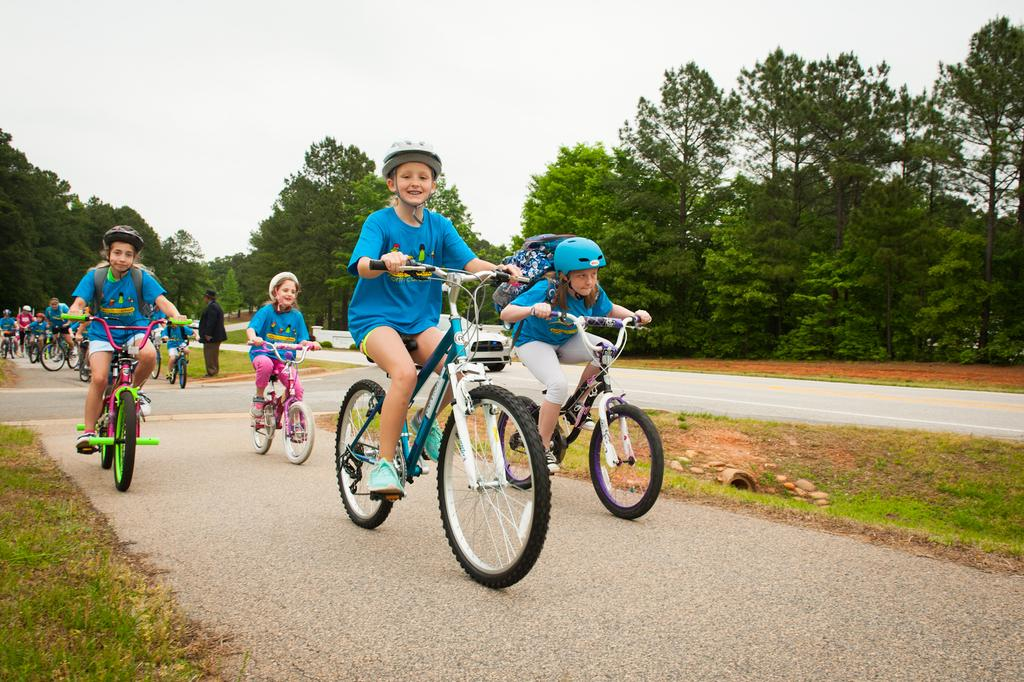What can be seen in the image involving children? There are children in the image, and they are riding bicycles. What are the children riding in the image? The children are riding bicycles. Where are the children riding their bicycles? The bicycles are on a road. What can be seen around the road in the image? There are trees around the road. What is the color of the sky in the image? The sky is white in color. What type of brass instrument can be heard playing in the image? There is no brass instrument or sound present in the image; it only shows children riding bicycles on a road. 